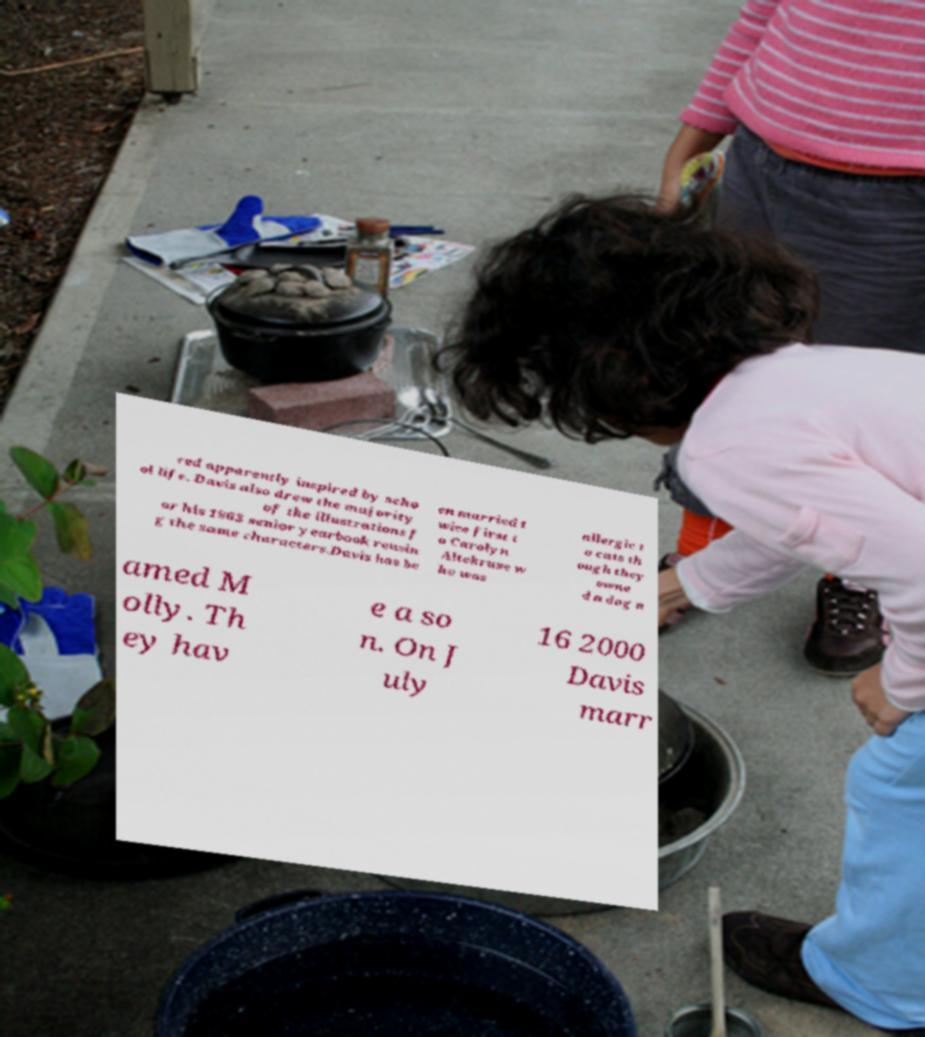Could you assist in decoding the text presented in this image and type it out clearly? red apparently inspired by scho ol life. Davis also drew the majority of the illustrations f or his 1963 senior yearbook reusin g the same characters.Davis has be en married t wice first t o Carolyn Altekruse w ho was allergic t o cats th ough they owne d a dog n amed M olly. Th ey hav e a so n. On J uly 16 2000 Davis marr 